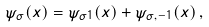<formula> <loc_0><loc_0><loc_500><loc_500>\psi _ { \sigma } ( x ) = \psi _ { \sigma 1 } ( x ) + \psi _ { \sigma , - 1 } ( x ) \, ,</formula> 